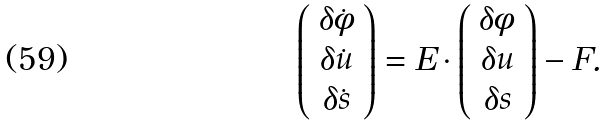<formula> <loc_0><loc_0><loc_500><loc_500>\left ( \begin{array} { c } \delta \dot { \phi } \\ \delta \dot { u } \\ \delta \dot { s } \end{array} \right ) = E \cdot \left ( \begin{array} { c } \delta \phi \\ \delta u \\ \delta s \end{array} \right ) - F .</formula> 